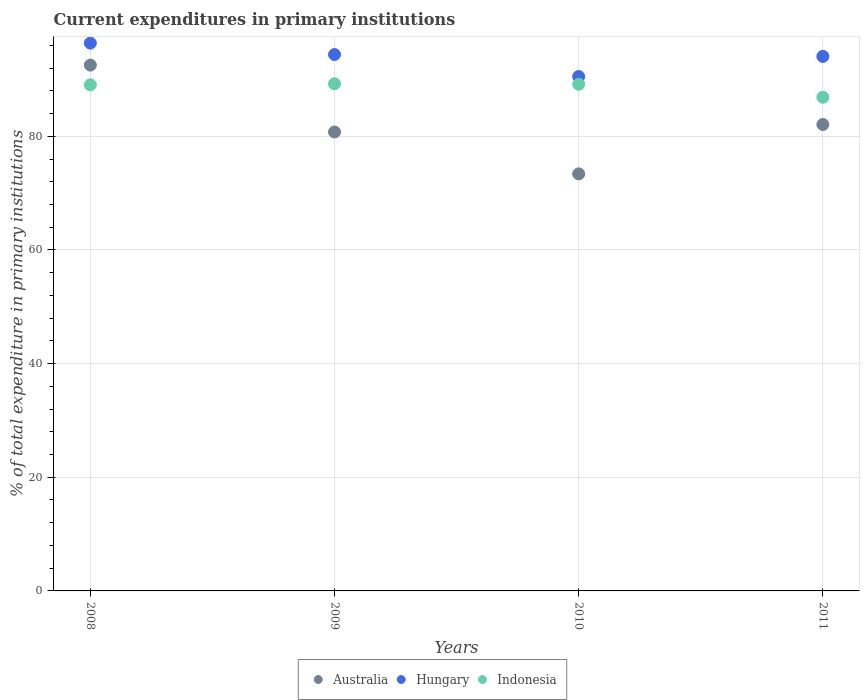How many different coloured dotlines are there?
Your answer should be very brief. 3. What is the current expenditures in primary institutions in Australia in 2010?
Ensure brevity in your answer.  73.38. Across all years, what is the maximum current expenditures in primary institutions in Hungary?
Ensure brevity in your answer.  96.39. Across all years, what is the minimum current expenditures in primary institutions in Hungary?
Your response must be concise. 90.51. In which year was the current expenditures in primary institutions in Indonesia maximum?
Keep it short and to the point. 2009. In which year was the current expenditures in primary institutions in Australia minimum?
Your answer should be compact. 2010. What is the total current expenditures in primary institutions in Indonesia in the graph?
Provide a short and direct response. 354.31. What is the difference between the current expenditures in primary institutions in Hungary in 2008 and that in 2009?
Give a very brief answer. 2.01. What is the difference between the current expenditures in primary institutions in Australia in 2008 and the current expenditures in primary institutions in Hungary in 2010?
Offer a terse response. 2.01. What is the average current expenditures in primary institutions in Indonesia per year?
Keep it short and to the point. 88.58. In the year 2008, what is the difference between the current expenditures in primary institutions in Hungary and current expenditures in primary institutions in Indonesia?
Your response must be concise. 7.34. In how many years, is the current expenditures in primary institutions in Indonesia greater than 16 %?
Ensure brevity in your answer.  4. What is the ratio of the current expenditures in primary institutions in Australia in 2008 to that in 2009?
Provide a short and direct response. 1.15. Is the current expenditures in primary institutions in Hungary in 2010 less than that in 2011?
Keep it short and to the point. Yes. Is the difference between the current expenditures in primary institutions in Hungary in 2008 and 2011 greater than the difference between the current expenditures in primary institutions in Indonesia in 2008 and 2011?
Your answer should be compact. Yes. What is the difference between the highest and the second highest current expenditures in primary institutions in Indonesia?
Your answer should be compact. 0.08. What is the difference between the highest and the lowest current expenditures in primary institutions in Indonesia?
Your answer should be very brief. 2.37. In how many years, is the current expenditures in primary institutions in Australia greater than the average current expenditures in primary institutions in Australia taken over all years?
Your answer should be very brief. 1. Is it the case that in every year, the sum of the current expenditures in primary institutions in Indonesia and current expenditures in primary institutions in Hungary  is greater than the current expenditures in primary institutions in Australia?
Provide a short and direct response. Yes. Does the current expenditures in primary institutions in Hungary monotonically increase over the years?
Your answer should be compact. No. Is the current expenditures in primary institutions in Hungary strictly greater than the current expenditures in primary institutions in Australia over the years?
Your answer should be very brief. Yes. Is the current expenditures in primary institutions in Australia strictly less than the current expenditures in primary institutions in Hungary over the years?
Keep it short and to the point. Yes. What is the difference between two consecutive major ticks on the Y-axis?
Keep it short and to the point. 20. What is the title of the graph?
Offer a very short reply. Current expenditures in primary institutions. Does "Mozambique" appear as one of the legend labels in the graph?
Your answer should be very brief. No. What is the label or title of the Y-axis?
Make the answer very short. % of total expenditure in primary institutions. What is the % of total expenditure in primary institutions of Australia in 2008?
Your response must be concise. 92.52. What is the % of total expenditure in primary institutions of Hungary in 2008?
Make the answer very short. 96.39. What is the % of total expenditure in primary institutions of Indonesia in 2008?
Ensure brevity in your answer.  89.06. What is the % of total expenditure in primary institutions of Australia in 2009?
Your response must be concise. 80.75. What is the % of total expenditure in primary institutions in Hungary in 2009?
Make the answer very short. 94.38. What is the % of total expenditure in primary institutions of Indonesia in 2009?
Your answer should be compact. 89.24. What is the % of total expenditure in primary institutions in Australia in 2010?
Offer a very short reply. 73.38. What is the % of total expenditure in primary institutions of Hungary in 2010?
Make the answer very short. 90.51. What is the % of total expenditure in primary institutions in Indonesia in 2010?
Provide a succinct answer. 89.15. What is the % of total expenditure in primary institutions in Australia in 2011?
Offer a terse response. 82.07. What is the % of total expenditure in primary institutions in Hungary in 2011?
Offer a very short reply. 94.05. What is the % of total expenditure in primary institutions of Indonesia in 2011?
Your response must be concise. 86.87. Across all years, what is the maximum % of total expenditure in primary institutions in Australia?
Offer a terse response. 92.52. Across all years, what is the maximum % of total expenditure in primary institutions of Hungary?
Give a very brief answer. 96.39. Across all years, what is the maximum % of total expenditure in primary institutions in Indonesia?
Make the answer very short. 89.24. Across all years, what is the minimum % of total expenditure in primary institutions of Australia?
Keep it short and to the point. 73.38. Across all years, what is the minimum % of total expenditure in primary institutions in Hungary?
Provide a short and direct response. 90.51. Across all years, what is the minimum % of total expenditure in primary institutions of Indonesia?
Your response must be concise. 86.87. What is the total % of total expenditure in primary institutions of Australia in the graph?
Provide a short and direct response. 328.72. What is the total % of total expenditure in primary institutions of Hungary in the graph?
Make the answer very short. 375.34. What is the total % of total expenditure in primary institutions in Indonesia in the graph?
Give a very brief answer. 354.31. What is the difference between the % of total expenditure in primary institutions of Australia in 2008 and that in 2009?
Offer a very short reply. 11.77. What is the difference between the % of total expenditure in primary institutions of Hungary in 2008 and that in 2009?
Offer a terse response. 2.01. What is the difference between the % of total expenditure in primary institutions in Indonesia in 2008 and that in 2009?
Ensure brevity in your answer.  -0.18. What is the difference between the % of total expenditure in primary institutions of Australia in 2008 and that in 2010?
Provide a short and direct response. 19.14. What is the difference between the % of total expenditure in primary institutions of Hungary in 2008 and that in 2010?
Offer a terse response. 5.88. What is the difference between the % of total expenditure in primary institutions in Indonesia in 2008 and that in 2010?
Your response must be concise. -0.1. What is the difference between the % of total expenditure in primary institutions in Australia in 2008 and that in 2011?
Keep it short and to the point. 10.45. What is the difference between the % of total expenditure in primary institutions of Hungary in 2008 and that in 2011?
Provide a short and direct response. 2.34. What is the difference between the % of total expenditure in primary institutions of Indonesia in 2008 and that in 2011?
Give a very brief answer. 2.19. What is the difference between the % of total expenditure in primary institutions of Australia in 2009 and that in 2010?
Your response must be concise. 7.38. What is the difference between the % of total expenditure in primary institutions in Hungary in 2009 and that in 2010?
Make the answer very short. 3.87. What is the difference between the % of total expenditure in primary institutions of Indonesia in 2009 and that in 2010?
Offer a very short reply. 0.08. What is the difference between the % of total expenditure in primary institutions in Australia in 2009 and that in 2011?
Ensure brevity in your answer.  -1.31. What is the difference between the % of total expenditure in primary institutions of Hungary in 2009 and that in 2011?
Offer a very short reply. 0.33. What is the difference between the % of total expenditure in primary institutions in Indonesia in 2009 and that in 2011?
Provide a succinct answer. 2.37. What is the difference between the % of total expenditure in primary institutions of Australia in 2010 and that in 2011?
Ensure brevity in your answer.  -8.69. What is the difference between the % of total expenditure in primary institutions in Hungary in 2010 and that in 2011?
Offer a very short reply. -3.54. What is the difference between the % of total expenditure in primary institutions of Indonesia in 2010 and that in 2011?
Offer a very short reply. 2.29. What is the difference between the % of total expenditure in primary institutions in Australia in 2008 and the % of total expenditure in primary institutions in Hungary in 2009?
Offer a terse response. -1.86. What is the difference between the % of total expenditure in primary institutions of Australia in 2008 and the % of total expenditure in primary institutions of Indonesia in 2009?
Your answer should be compact. 3.28. What is the difference between the % of total expenditure in primary institutions in Hungary in 2008 and the % of total expenditure in primary institutions in Indonesia in 2009?
Make the answer very short. 7.16. What is the difference between the % of total expenditure in primary institutions of Australia in 2008 and the % of total expenditure in primary institutions of Hungary in 2010?
Ensure brevity in your answer.  2.01. What is the difference between the % of total expenditure in primary institutions of Australia in 2008 and the % of total expenditure in primary institutions of Indonesia in 2010?
Provide a short and direct response. 3.37. What is the difference between the % of total expenditure in primary institutions of Hungary in 2008 and the % of total expenditure in primary institutions of Indonesia in 2010?
Your answer should be compact. 7.24. What is the difference between the % of total expenditure in primary institutions of Australia in 2008 and the % of total expenditure in primary institutions of Hungary in 2011?
Keep it short and to the point. -1.53. What is the difference between the % of total expenditure in primary institutions of Australia in 2008 and the % of total expenditure in primary institutions of Indonesia in 2011?
Your answer should be very brief. 5.66. What is the difference between the % of total expenditure in primary institutions in Hungary in 2008 and the % of total expenditure in primary institutions in Indonesia in 2011?
Keep it short and to the point. 9.53. What is the difference between the % of total expenditure in primary institutions of Australia in 2009 and the % of total expenditure in primary institutions of Hungary in 2010?
Provide a succinct answer. -9.76. What is the difference between the % of total expenditure in primary institutions in Australia in 2009 and the % of total expenditure in primary institutions in Indonesia in 2010?
Make the answer very short. -8.4. What is the difference between the % of total expenditure in primary institutions of Hungary in 2009 and the % of total expenditure in primary institutions of Indonesia in 2010?
Make the answer very short. 5.23. What is the difference between the % of total expenditure in primary institutions of Australia in 2009 and the % of total expenditure in primary institutions of Hungary in 2011?
Offer a terse response. -13.3. What is the difference between the % of total expenditure in primary institutions of Australia in 2009 and the % of total expenditure in primary institutions of Indonesia in 2011?
Offer a terse response. -6.11. What is the difference between the % of total expenditure in primary institutions in Hungary in 2009 and the % of total expenditure in primary institutions in Indonesia in 2011?
Ensure brevity in your answer.  7.52. What is the difference between the % of total expenditure in primary institutions in Australia in 2010 and the % of total expenditure in primary institutions in Hungary in 2011?
Make the answer very short. -20.67. What is the difference between the % of total expenditure in primary institutions of Australia in 2010 and the % of total expenditure in primary institutions of Indonesia in 2011?
Your answer should be very brief. -13.49. What is the difference between the % of total expenditure in primary institutions in Hungary in 2010 and the % of total expenditure in primary institutions in Indonesia in 2011?
Your answer should be very brief. 3.65. What is the average % of total expenditure in primary institutions in Australia per year?
Ensure brevity in your answer.  82.18. What is the average % of total expenditure in primary institutions of Hungary per year?
Provide a succinct answer. 93.83. What is the average % of total expenditure in primary institutions in Indonesia per year?
Offer a terse response. 88.58. In the year 2008, what is the difference between the % of total expenditure in primary institutions of Australia and % of total expenditure in primary institutions of Hungary?
Your response must be concise. -3.87. In the year 2008, what is the difference between the % of total expenditure in primary institutions in Australia and % of total expenditure in primary institutions in Indonesia?
Provide a succinct answer. 3.47. In the year 2008, what is the difference between the % of total expenditure in primary institutions in Hungary and % of total expenditure in primary institutions in Indonesia?
Keep it short and to the point. 7.34. In the year 2009, what is the difference between the % of total expenditure in primary institutions in Australia and % of total expenditure in primary institutions in Hungary?
Ensure brevity in your answer.  -13.63. In the year 2009, what is the difference between the % of total expenditure in primary institutions in Australia and % of total expenditure in primary institutions in Indonesia?
Give a very brief answer. -8.48. In the year 2009, what is the difference between the % of total expenditure in primary institutions of Hungary and % of total expenditure in primary institutions of Indonesia?
Ensure brevity in your answer.  5.15. In the year 2010, what is the difference between the % of total expenditure in primary institutions of Australia and % of total expenditure in primary institutions of Hungary?
Your response must be concise. -17.13. In the year 2010, what is the difference between the % of total expenditure in primary institutions in Australia and % of total expenditure in primary institutions in Indonesia?
Your answer should be compact. -15.77. In the year 2010, what is the difference between the % of total expenditure in primary institutions in Hungary and % of total expenditure in primary institutions in Indonesia?
Your answer should be compact. 1.36. In the year 2011, what is the difference between the % of total expenditure in primary institutions in Australia and % of total expenditure in primary institutions in Hungary?
Offer a very short reply. -11.98. In the year 2011, what is the difference between the % of total expenditure in primary institutions of Australia and % of total expenditure in primary institutions of Indonesia?
Offer a very short reply. -4.8. In the year 2011, what is the difference between the % of total expenditure in primary institutions in Hungary and % of total expenditure in primary institutions in Indonesia?
Your response must be concise. 7.19. What is the ratio of the % of total expenditure in primary institutions in Australia in 2008 to that in 2009?
Your answer should be very brief. 1.15. What is the ratio of the % of total expenditure in primary institutions in Hungary in 2008 to that in 2009?
Keep it short and to the point. 1.02. What is the ratio of the % of total expenditure in primary institutions in Australia in 2008 to that in 2010?
Offer a terse response. 1.26. What is the ratio of the % of total expenditure in primary institutions in Hungary in 2008 to that in 2010?
Provide a short and direct response. 1.06. What is the ratio of the % of total expenditure in primary institutions of Indonesia in 2008 to that in 2010?
Keep it short and to the point. 1. What is the ratio of the % of total expenditure in primary institutions of Australia in 2008 to that in 2011?
Keep it short and to the point. 1.13. What is the ratio of the % of total expenditure in primary institutions of Hungary in 2008 to that in 2011?
Keep it short and to the point. 1.02. What is the ratio of the % of total expenditure in primary institutions of Indonesia in 2008 to that in 2011?
Provide a short and direct response. 1.03. What is the ratio of the % of total expenditure in primary institutions in Australia in 2009 to that in 2010?
Ensure brevity in your answer.  1.1. What is the ratio of the % of total expenditure in primary institutions in Hungary in 2009 to that in 2010?
Keep it short and to the point. 1.04. What is the ratio of the % of total expenditure in primary institutions in Australia in 2009 to that in 2011?
Make the answer very short. 0.98. What is the ratio of the % of total expenditure in primary institutions of Indonesia in 2009 to that in 2011?
Offer a very short reply. 1.03. What is the ratio of the % of total expenditure in primary institutions in Australia in 2010 to that in 2011?
Give a very brief answer. 0.89. What is the ratio of the % of total expenditure in primary institutions of Hungary in 2010 to that in 2011?
Keep it short and to the point. 0.96. What is the ratio of the % of total expenditure in primary institutions in Indonesia in 2010 to that in 2011?
Provide a succinct answer. 1.03. What is the difference between the highest and the second highest % of total expenditure in primary institutions in Australia?
Keep it short and to the point. 10.45. What is the difference between the highest and the second highest % of total expenditure in primary institutions in Hungary?
Provide a succinct answer. 2.01. What is the difference between the highest and the second highest % of total expenditure in primary institutions in Indonesia?
Your answer should be very brief. 0.08. What is the difference between the highest and the lowest % of total expenditure in primary institutions in Australia?
Ensure brevity in your answer.  19.14. What is the difference between the highest and the lowest % of total expenditure in primary institutions in Hungary?
Your answer should be compact. 5.88. What is the difference between the highest and the lowest % of total expenditure in primary institutions of Indonesia?
Make the answer very short. 2.37. 